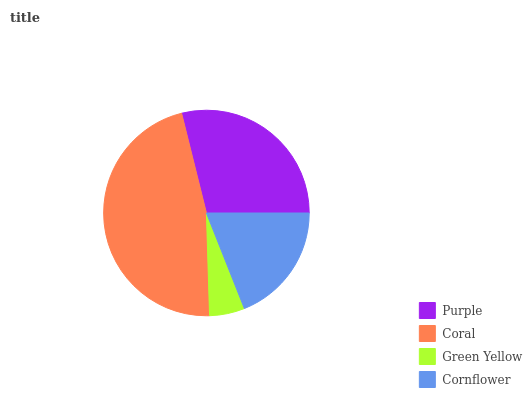Is Green Yellow the minimum?
Answer yes or no. Yes. Is Coral the maximum?
Answer yes or no. Yes. Is Coral the minimum?
Answer yes or no. No. Is Green Yellow the maximum?
Answer yes or no. No. Is Coral greater than Green Yellow?
Answer yes or no. Yes. Is Green Yellow less than Coral?
Answer yes or no. Yes. Is Green Yellow greater than Coral?
Answer yes or no. No. Is Coral less than Green Yellow?
Answer yes or no. No. Is Purple the high median?
Answer yes or no. Yes. Is Cornflower the low median?
Answer yes or no. Yes. Is Cornflower the high median?
Answer yes or no. No. Is Purple the low median?
Answer yes or no. No. 